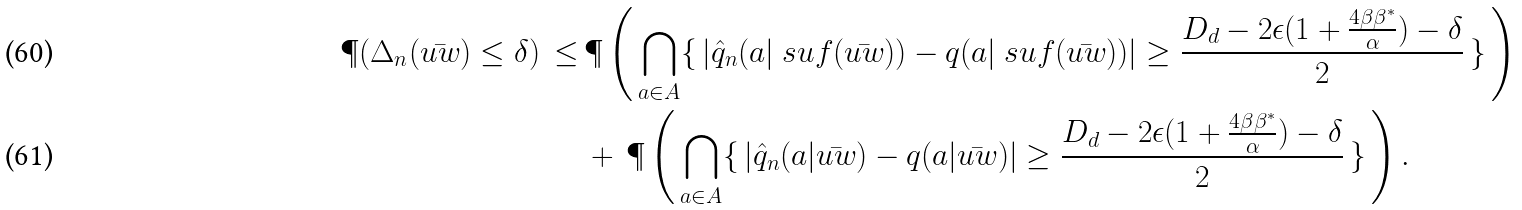Convert formula to latex. <formula><loc_0><loc_0><loc_500><loc_500>\P ( \Delta _ { n } ( \bar { u w } ) \leq \delta ) \, \leq \, & \P \left ( \, \bigcap _ { a \in A } \{ \, | \hat { q } _ { n } ( a | \ s u f ( \bar { u w } ) ) - q ( a | \ s u f ( \bar { u w } ) ) | \geq \frac { D _ { d } - 2 \epsilon ( 1 + \frac { 4 \beta \beta ^ { * } } { \alpha } ) - \delta } 2 \, \} \, \right ) \\ & + \, \P \left ( \, \bigcap _ { a \in A } \{ \, | \hat { q } _ { n } ( a | \bar { u w } ) - q ( a | \bar { u w } ) | \geq \frac { D _ { d } - 2 \epsilon ( 1 + \frac { 4 \beta \beta ^ { * } } { \alpha } ) - \delta } 2 \, \} \, \right ) \/ .</formula> 